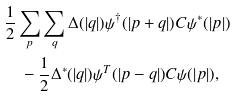<formula> <loc_0><loc_0><loc_500><loc_500>& \frac { 1 } { 2 } \sum _ { p } \sum _ { q } \Delta ( | { q } | ) \psi ^ { \dagger } ( | { p + q } | ) C \psi ^ { * } ( | { p } | ) \\ & \quad - \frac { 1 } { 2 } \Delta ^ { * } ( | { q } | ) \psi ^ { T } ( | { p - q } | ) C \psi ( | { p } | ) ,</formula> 